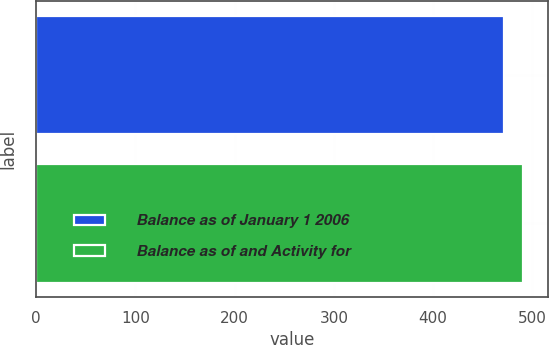Convert chart. <chart><loc_0><loc_0><loc_500><loc_500><bar_chart><fcel>Balance as of January 1 2006<fcel>Balance as of and Activity for<nl><fcel>472<fcel>491<nl></chart> 